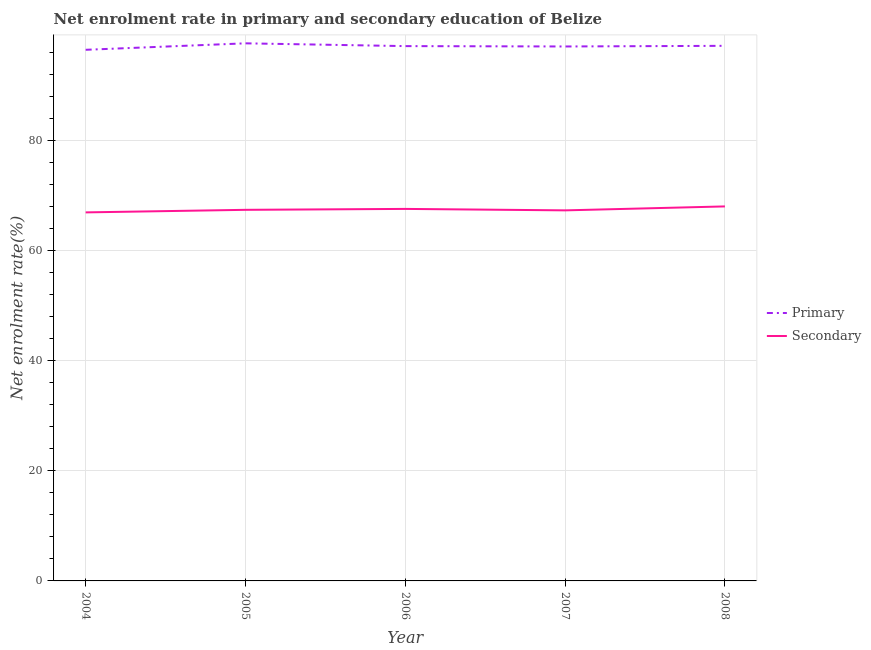Is the number of lines equal to the number of legend labels?
Give a very brief answer. Yes. What is the enrollment rate in primary education in 2005?
Offer a very short reply. 97.6. Across all years, what is the maximum enrollment rate in primary education?
Make the answer very short. 97.6. Across all years, what is the minimum enrollment rate in secondary education?
Keep it short and to the point. 66.91. In which year was the enrollment rate in secondary education minimum?
Make the answer very short. 2004. What is the total enrollment rate in primary education in the graph?
Offer a terse response. 485.29. What is the difference between the enrollment rate in primary education in 2005 and that in 2008?
Your answer should be compact. 0.45. What is the difference between the enrollment rate in primary education in 2006 and the enrollment rate in secondary education in 2005?
Provide a succinct answer. 29.72. What is the average enrollment rate in secondary education per year?
Offer a very short reply. 67.42. In the year 2004, what is the difference between the enrollment rate in secondary education and enrollment rate in primary education?
Offer a terse response. -29.52. What is the ratio of the enrollment rate in primary education in 2007 to that in 2008?
Your answer should be compact. 1. Is the difference between the enrollment rate in primary education in 2007 and 2008 greater than the difference between the enrollment rate in secondary education in 2007 and 2008?
Offer a very short reply. Yes. What is the difference between the highest and the second highest enrollment rate in secondary education?
Give a very brief answer. 0.45. What is the difference between the highest and the lowest enrollment rate in secondary education?
Ensure brevity in your answer.  1.08. In how many years, is the enrollment rate in primary education greater than the average enrollment rate in primary education taken over all years?
Make the answer very short. 3. Is the sum of the enrollment rate in primary education in 2004 and 2007 greater than the maximum enrollment rate in secondary education across all years?
Your answer should be compact. Yes. Does the enrollment rate in primary education monotonically increase over the years?
Your response must be concise. No. Is the enrollment rate in primary education strictly greater than the enrollment rate in secondary education over the years?
Ensure brevity in your answer.  Yes. Is the enrollment rate in primary education strictly less than the enrollment rate in secondary education over the years?
Provide a succinct answer. No. What is the difference between two consecutive major ticks on the Y-axis?
Provide a short and direct response. 20. Are the values on the major ticks of Y-axis written in scientific E-notation?
Offer a very short reply. No. Does the graph contain any zero values?
Your answer should be very brief. No. Does the graph contain grids?
Provide a succinct answer. Yes. Where does the legend appear in the graph?
Offer a very short reply. Center right. How many legend labels are there?
Your answer should be compact. 2. What is the title of the graph?
Your answer should be compact. Net enrolment rate in primary and secondary education of Belize. Does "Non-resident workers" appear as one of the legend labels in the graph?
Offer a terse response. No. What is the label or title of the Y-axis?
Give a very brief answer. Net enrolment rate(%). What is the Net enrolment rate(%) of Primary in 2004?
Offer a very short reply. 96.42. What is the Net enrolment rate(%) in Secondary in 2004?
Offer a terse response. 66.91. What is the Net enrolment rate(%) in Primary in 2005?
Your answer should be compact. 97.6. What is the Net enrolment rate(%) of Secondary in 2005?
Ensure brevity in your answer.  67.37. What is the Net enrolment rate(%) of Primary in 2006?
Provide a succinct answer. 97.09. What is the Net enrolment rate(%) in Secondary in 2006?
Make the answer very short. 67.54. What is the Net enrolment rate(%) in Primary in 2007?
Offer a very short reply. 97.03. What is the Net enrolment rate(%) of Secondary in 2007?
Make the answer very short. 67.27. What is the Net enrolment rate(%) in Primary in 2008?
Ensure brevity in your answer.  97.15. What is the Net enrolment rate(%) of Secondary in 2008?
Your answer should be very brief. 67.99. Across all years, what is the maximum Net enrolment rate(%) in Primary?
Provide a succinct answer. 97.6. Across all years, what is the maximum Net enrolment rate(%) of Secondary?
Keep it short and to the point. 67.99. Across all years, what is the minimum Net enrolment rate(%) in Primary?
Offer a very short reply. 96.42. Across all years, what is the minimum Net enrolment rate(%) in Secondary?
Make the answer very short. 66.91. What is the total Net enrolment rate(%) of Primary in the graph?
Offer a very short reply. 485.29. What is the total Net enrolment rate(%) of Secondary in the graph?
Ensure brevity in your answer.  337.08. What is the difference between the Net enrolment rate(%) of Primary in 2004 and that in 2005?
Offer a terse response. -1.17. What is the difference between the Net enrolment rate(%) of Secondary in 2004 and that in 2005?
Keep it short and to the point. -0.46. What is the difference between the Net enrolment rate(%) in Primary in 2004 and that in 2006?
Offer a very short reply. -0.67. What is the difference between the Net enrolment rate(%) of Secondary in 2004 and that in 2006?
Offer a terse response. -0.63. What is the difference between the Net enrolment rate(%) of Primary in 2004 and that in 2007?
Give a very brief answer. -0.6. What is the difference between the Net enrolment rate(%) of Secondary in 2004 and that in 2007?
Provide a short and direct response. -0.37. What is the difference between the Net enrolment rate(%) in Primary in 2004 and that in 2008?
Make the answer very short. -0.72. What is the difference between the Net enrolment rate(%) in Secondary in 2004 and that in 2008?
Ensure brevity in your answer.  -1.08. What is the difference between the Net enrolment rate(%) of Primary in 2005 and that in 2006?
Provide a short and direct response. 0.51. What is the difference between the Net enrolment rate(%) in Secondary in 2005 and that in 2006?
Give a very brief answer. -0.17. What is the difference between the Net enrolment rate(%) of Primary in 2005 and that in 2007?
Offer a terse response. 0.57. What is the difference between the Net enrolment rate(%) in Secondary in 2005 and that in 2007?
Ensure brevity in your answer.  0.1. What is the difference between the Net enrolment rate(%) in Primary in 2005 and that in 2008?
Make the answer very short. 0.45. What is the difference between the Net enrolment rate(%) in Secondary in 2005 and that in 2008?
Give a very brief answer. -0.62. What is the difference between the Net enrolment rate(%) of Primary in 2006 and that in 2007?
Your response must be concise. 0.07. What is the difference between the Net enrolment rate(%) of Secondary in 2006 and that in 2007?
Offer a very short reply. 0.27. What is the difference between the Net enrolment rate(%) of Primary in 2006 and that in 2008?
Your response must be concise. -0.05. What is the difference between the Net enrolment rate(%) in Secondary in 2006 and that in 2008?
Keep it short and to the point. -0.45. What is the difference between the Net enrolment rate(%) of Primary in 2007 and that in 2008?
Provide a succinct answer. -0.12. What is the difference between the Net enrolment rate(%) of Secondary in 2007 and that in 2008?
Ensure brevity in your answer.  -0.72. What is the difference between the Net enrolment rate(%) in Primary in 2004 and the Net enrolment rate(%) in Secondary in 2005?
Offer a very short reply. 29.05. What is the difference between the Net enrolment rate(%) in Primary in 2004 and the Net enrolment rate(%) in Secondary in 2006?
Ensure brevity in your answer.  28.89. What is the difference between the Net enrolment rate(%) of Primary in 2004 and the Net enrolment rate(%) of Secondary in 2007?
Your response must be concise. 29.15. What is the difference between the Net enrolment rate(%) of Primary in 2004 and the Net enrolment rate(%) of Secondary in 2008?
Provide a succinct answer. 28.43. What is the difference between the Net enrolment rate(%) in Primary in 2005 and the Net enrolment rate(%) in Secondary in 2006?
Keep it short and to the point. 30.06. What is the difference between the Net enrolment rate(%) of Primary in 2005 and the Net enrolment rate(%) of Secondary in 2007?
Your response must be concise. 30.33. What is the difference between the Net enrolment rate(%) in Primary in 2005 and the Net enrolment rate(%) in Secondary in 2008?
Provide a short and direct response. 29.61. What is the difference between the Net enrolment rate(%) in Primary in 2006 and the Net enrolment rate(%) in Secondary in 2007?
Provide a succinct answer. 29.82. What is the difference between the Net enrolment rate(%) in Primary in 2006 and the Net enrolment rate(%) in Secondary in 2008?
Your response must be concise. 29.1. What is the difference between the Net enrolment rate(%) in Primary in 2007 and the Net enrolment rate(%) in Secondary in 2008?
Provide a succinct answer. 29.04. What is the average Net enrolment rate(%) in Primary per year?
Provide a succinct answer. 97.06. What is the average Net enrolment rate(%) of Secondary per year?
Your response must be concise. 67.42. In the year 2004, what is the difference between the Net enrolment rate(%) of Primary and Net enrolment rate(%) of Secondary?
Your answer should be compact. 29.52. In the year 2005, what is the difference between the Net enrolment rate(%) in Primary and Net enrolment rate(%) in Secondary?
Your response must be concise. 30.23. In the year 2006, what is the difference between the Net enrolment rate(%) of Primary and Net enrolment rate(%) of Secondary?
Provide a short and direct response. 29.56. In the year 2007, what is the difference between the Net enrolment rate(%) in Primary and Net enrolment rate(%) in Secondary?
Provide a short and direct response. 29.75. In the year 2008, what is the difference between the Net enrolment rate(%) of Primary and Net enrolment rate(%) of Secondary?
Offer a very short reply. 29.16. What is the ratio of the Net enrolment rate(%) of Primary in 2004 to that in 2005?
Keep it short and to the point. 0.99. What is the ratio of the Net enrolment rate(%) in Secondary in 2004 to that in 2006?
Keep it short and to the point. 0.99. What is the ratio of the Net enrolment rate(%) in Secondary in 2004 to that in 2008?
Give a very brief answer. 0.98. What is the ratio of the Net enrolment rate(%) in Primary in 2005 to that in 2006?
Make the answer very short. 1.01. What is the ratio of the Net enrolment rate(%) in Secondary in 2005 to that in 2006?
Your response must be concise. 1. What is the ratio of the Net enrolment rate(%) in Primary in 2005 to that in 2007?
Give a very brief answer. 1.01. What is the ratio of the Net enrolment rate(%) in Secondary in 2005 to that in 2007?
Ensure brevity in your answer.  1. What is the ratio of the Net enrolment rate(%) in Secondary in 2005 to that in 2008?
Provide a short and direct response. 0.99. What is the ratio of the Net enrolment rate(%) in Secondary in 2006 to that in 2007?
Your answer should be compact. 1. What is the difference between the highest and the second highest Net enrolment rate(%) in Primary?
Ensure brevity in your answer.  0.45. What is the difference between the highest and the second highest Net enrolment rate(%) of Secondary?
Offer a very short reply. 0.45. What is the difference between the highest and the lowest Net enrolment rate(%) of Primary?
Your answer should be very brief. 1.17. What is the difference between the highest and the lowest Net enrolment rate(%) in Secondary?
Your answer should be very brief. 1.08. 